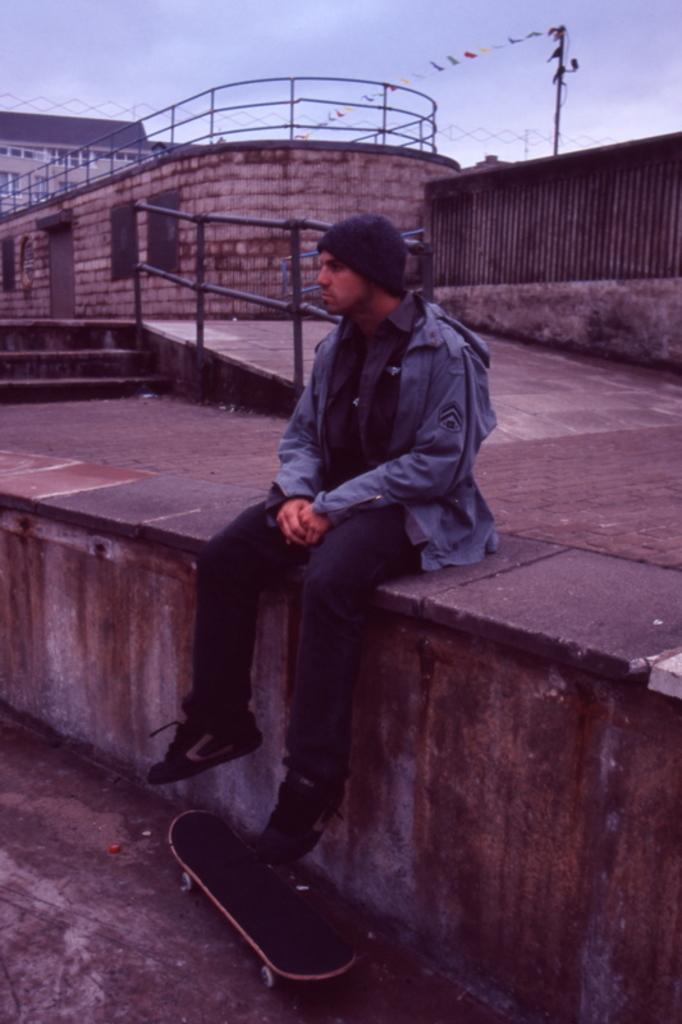Can you describe this image briefly? There is one man wearing a cap and sitting on a wall in the middle of this image. There is a skateboard at the bottom of this image, and there is a building in the background. There is a sky at the top of this image. 